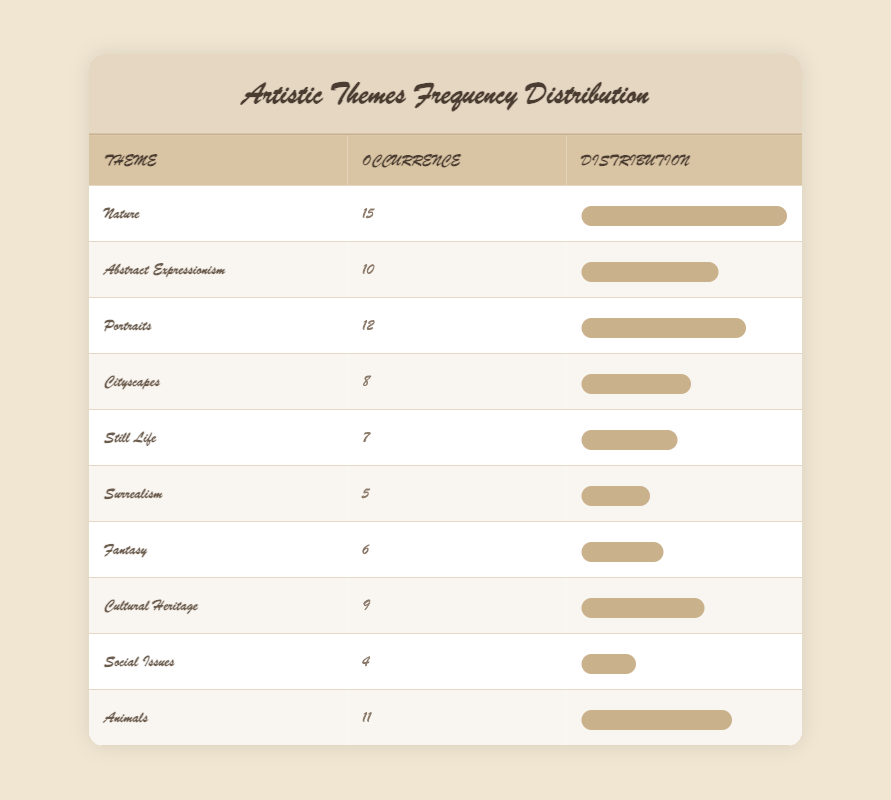What is the most frequently occurring theme among the students' paintings? The most frequently occurring theme is listed at the top of the table, which shows 'Nature' with an occurrence of 15.
Answer: Nature How many themes have an occurrence of 10 or more? By counting the themes with an occurrence of 10 or higher, we find 'Nature' (15), 'Abstract Expressionism' (10), 'Portraits' (12), 'Animals' (11), and 'Cultural Heritage' (9). This gives us a total of 5 themes.
Answer: 5 Is there a theme that has less than 5 occurrences? Looking at the table, the least occurring theme is 'Social Issues', which has an occurrence of 4. Since there are no themes with occurrences less than 4, the statement is true.
Answer: No What is the difference in occurrences between the theme with the highest and the lowest frequency? The highest frequency is 'Nature' with 15 occurrences and the lowest is 'Social Issues' with 4 occurrences. The difference is calculated as 15 - 4 = 11.
Answer: 11 On average, how many occurrences do the themes represent? To find the average occurrence, sum all occurrences: 15 + 10 + 12 + 8 + 7 + 5 + 6 + 9 + 4 + 11 = 87. There are 10 themes, so we divide 87 by 10, which equals 8.7.
Answer: 8.7 How many themes relate to animals and nature combined? The themes related to animals are 'Animals' (11) and 'Nature' (15). Their occurrences combined amount to 15 + 11 = 26.
Answer: 26 Is 'Surrealism' more frequently occurring than 'Fantasy'? 'Surrealism' has 5 occurrences while 'Fantasy' has 6. Since 5 is less than 6, this statement is false.
Answer: No Which theme has the least occurrences and how does it relate to the theme with the most occurrences? The theme with the least occurrences is 'Social Issues' with 4 occurrences, compared to 'Nature', which has 15 occurrences. The relationship indicates that 'Social Issues' is significantly less popular in this dataset.
Answer: Social Issues (4) compared to Nature (15) 